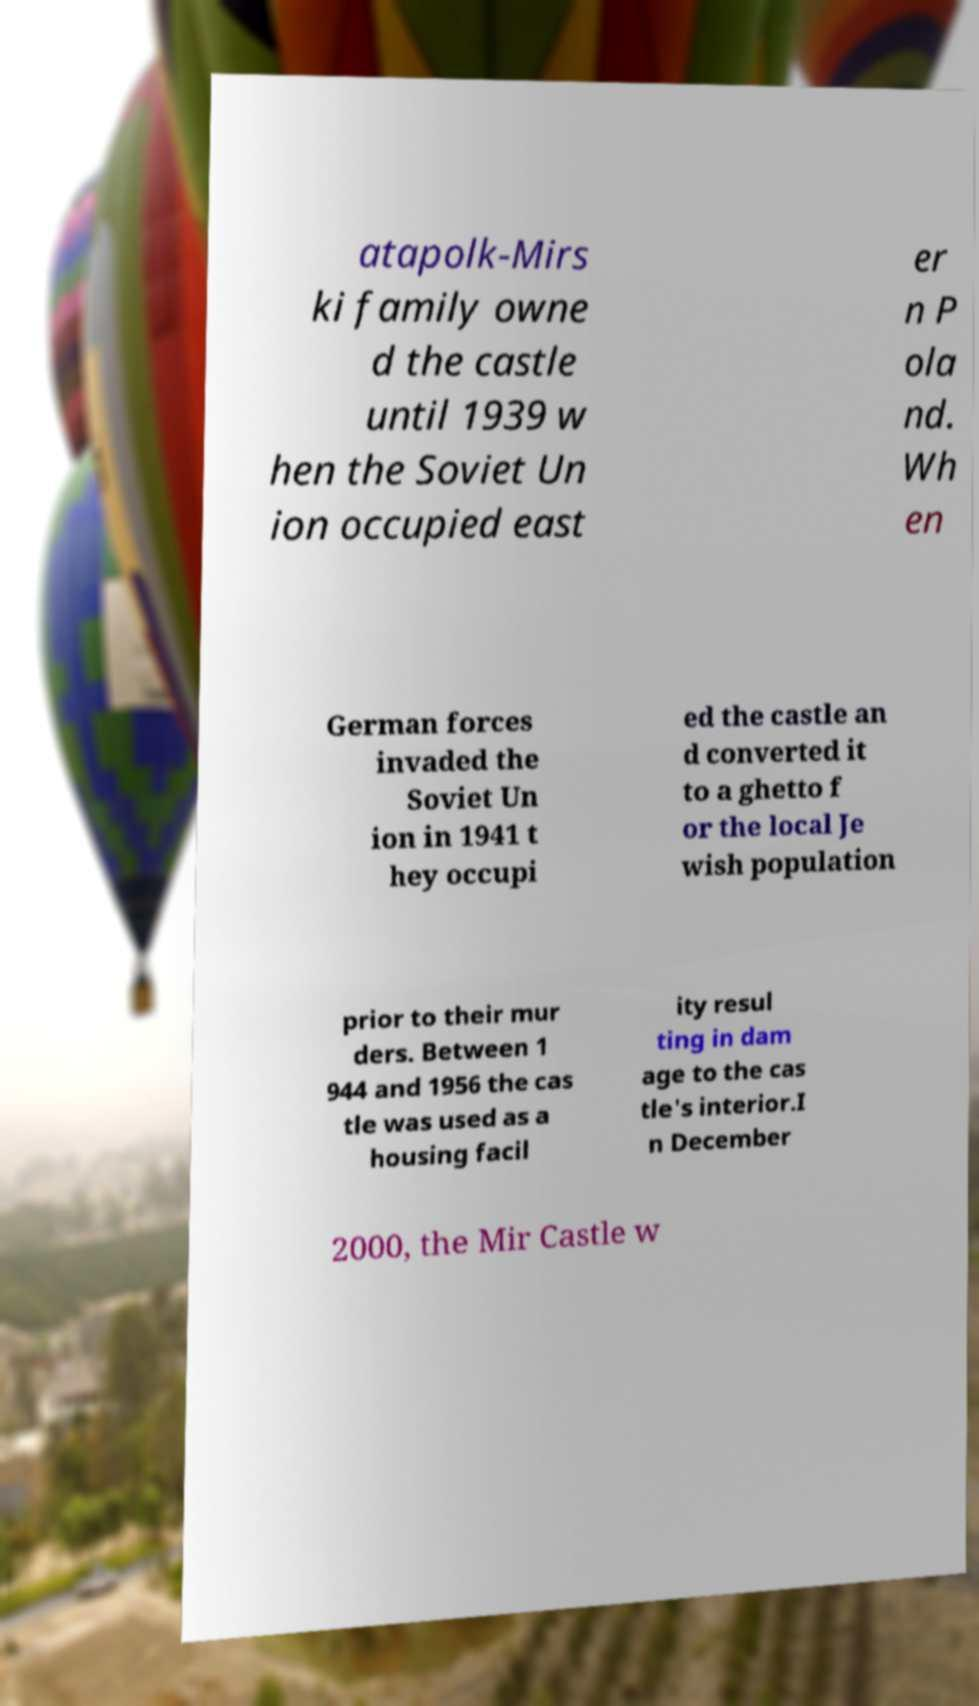Could you extract and type out the text from this image? atapolk-Mirs ki family owne d the castle until 1939 w hen the Soviet Un ion occupied east er n P ola nd. Wh en German forces invaded the Soviet Un ion in 1941 t hey occupi ed the castle an d converted it to a ghetto f or the local Je wish population prior to their mur ders. Between 1 944 and 1956 the cas tle was used as a housing facil ity resul ting in dam age to the cas tle's interior.I n December 2000, the Mir Castle w 